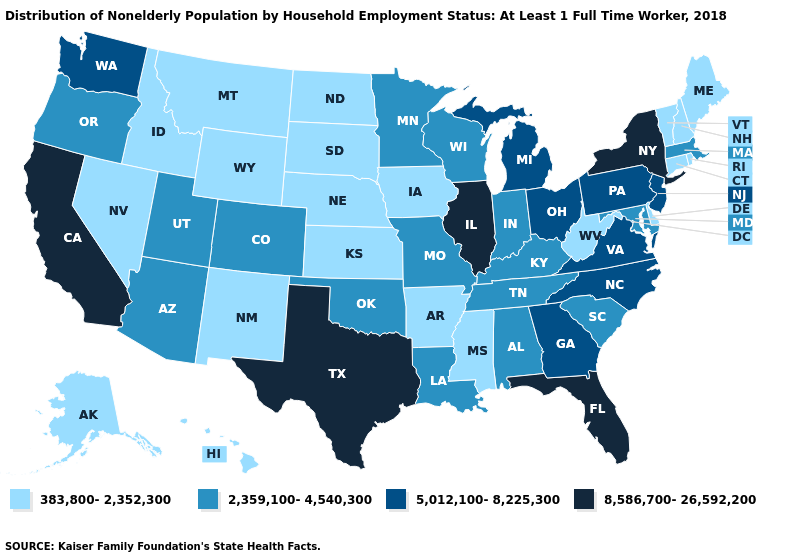What is the value of Idaho?
Quick response, please. 383,800-2,352,300. Does Arizona have a higher value than Oregon?
Keep it brief. No. Name the states that have a value in the range 8,586,700-26,592,200?
Concise answer only. California, Florida, Illinois, New York, Texas. Which states have the lowest value in the MidWest?
Concise answer only. Iowa, Kansas, Nebraska, North Dakota, South Dakota. Among the states that border California , which have the highest value?
Write a very short answer. Arizona, Oregon. What is the lowest value in the MidWest?
Give a very brief answer. 383,800-2,352,300. Does Wyoming have the lowest value in the West?
Short answer required. Yes. What is the value of Wyoming?
Concise answer only. 383,800-2,352,300. Does Washington have the lowest value in the USA?
Short answer required. No. What is the value of Minnesota?
Give a very brief answer. 2,359,100-4,540,300. How many symbols are there in the legend?
Be succinct. 4. Name the states that have a value in the range 383,800-2,352,300?
Short answer required. Alaska, Arkansas, Connecticut, Delaware, Hawaii, Idaho, Iowa, Kansas, Maine, Mississippi, Montana, Nebraska, Nevada, New Hampshire, New Mexico, North Dakota, Rhode Island, South Dakota, Vermont, West Virginia, Wyoming. Which states have the lowest value in the South?
Quick response, please. Arkansas, Delaware, Mississippi, West Virginia. Does the map have missing data?
Write a very short answer. No. Name the states that have a value in the range 2,359,100-4,540,300?
Quick response, please. Alabama, Arizona, Colorado, Indiana, Kentucky, Louisiana, Maryland, Massachusetts, Minnesota, Missouri, Oklahoma, Oregon, South Carolina, Tennessee, Utah, Wisconsin. 